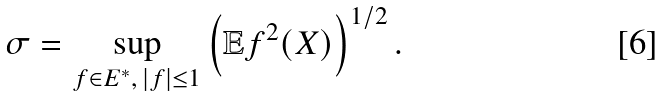Convert formula to latex. <formula><loc_0><loc_0><loc_500><loc_500>\sigma = \sup _ { f \in E ^ { * } , \, | f | \leq 1 } \left ( \mathbb { E } f ^ { 2 } ( X ) \right ) ^ { 1 / 2 } .</formula> 